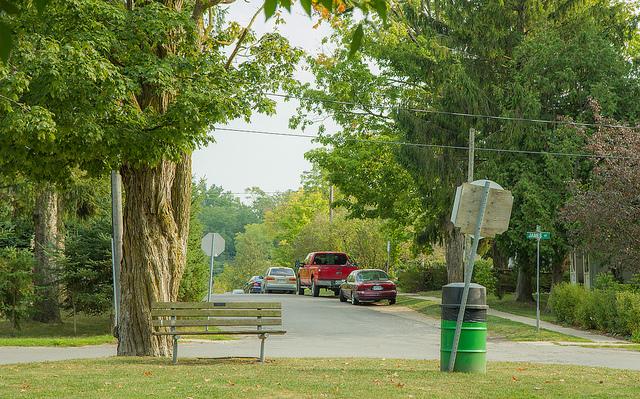Is the grass green?
Concise answer only. Yes. What is hanging from the pole?
Give a very brief answer. Sign. What color is the trash can?
Quick response, please. Green. What is shadow of?
Answer briefly. Trees. Where could someone sit and take a rest?
Answer briefly. Bench. Was this picture taken at a zoo?
Keep it brief. No. What type of vehicle is the second from the last?
Concise answer only. Truck. Where is the car parked?
Quick response, please. Roadside. Who is sitting on the bench?
Keep it brief. No 1. What is the thing in the center of the concrete square?
Give a very brief answer. Sign. Is that a good tree for climbing?
Be succinct. Yes. What is the closest object in the picture?
Be succinct. Sign. 